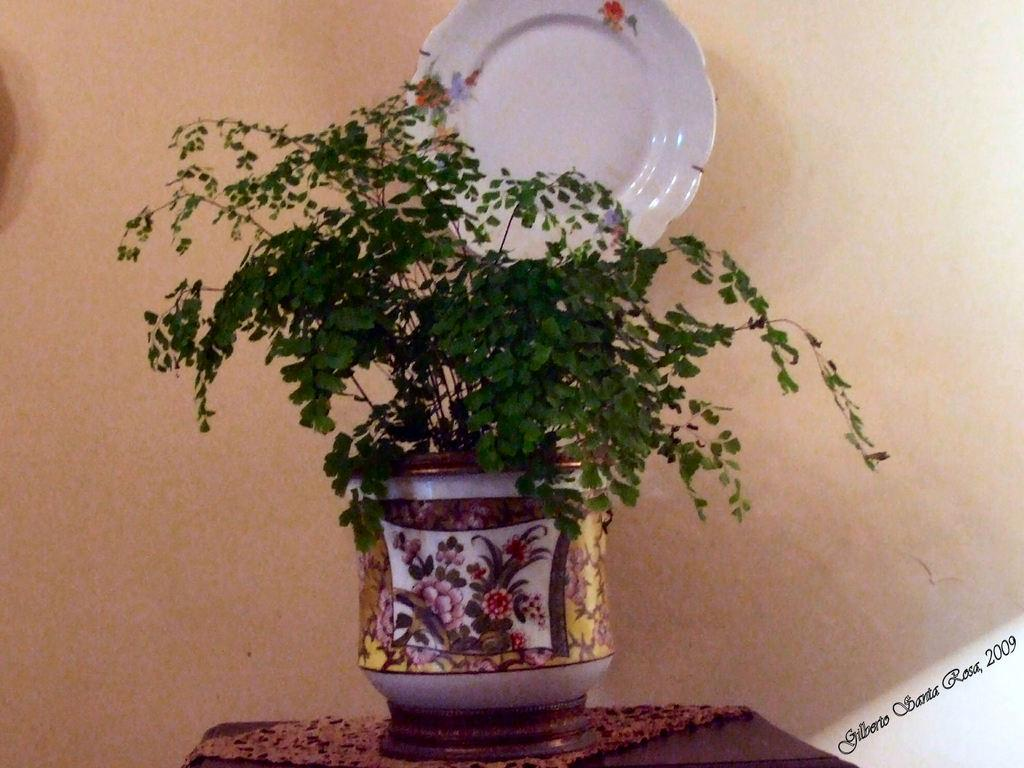What can be seen on the wall in the background of the image? There is a designed plate on the wall in the background. What type of living organism is present in the image? There is a plant in the image. What is the pot used for in the image? The pot is used to hold the plant. Can you describe the objects in the image? There are objects in the image, but their specific nature is not mentioned in the provided facts. What is the watermark in the image? There is a watermark in the bottom right corner of the image. What type of vest is being worn by the plant in the image? There is no vest present in the image, as the plant is not a living organism that wears clothing. 